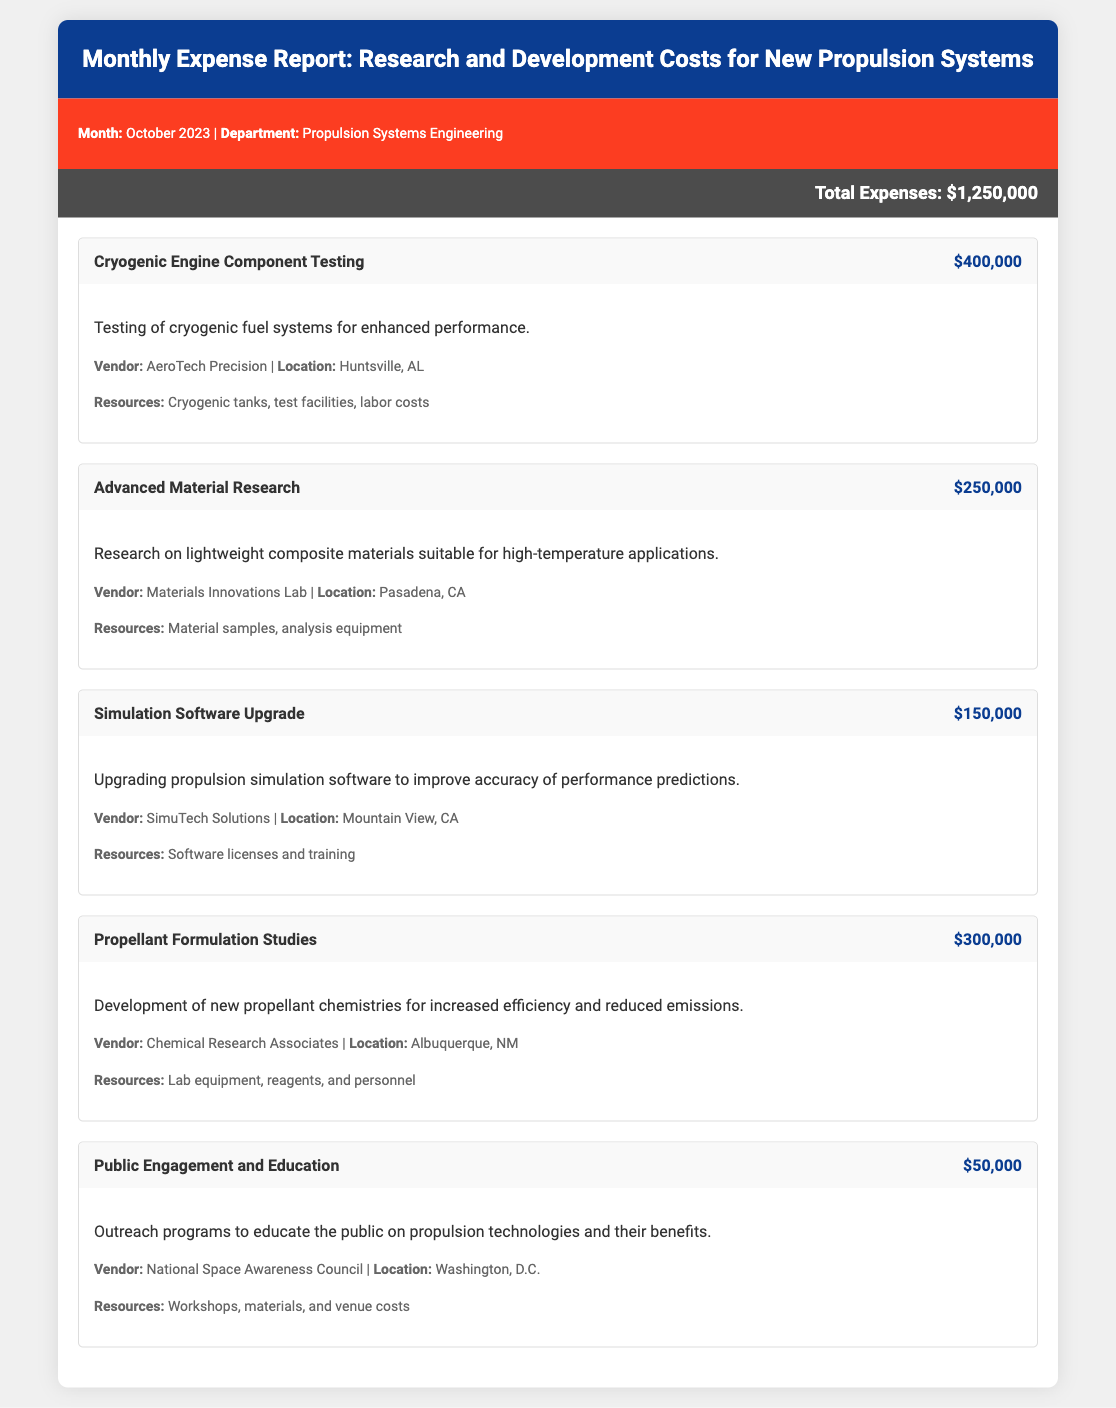What is the total expense for October 2023? The total expense is explicitly stated in the document, which is $1,250,000.
Answer: $1,250,000 How much was spent on Cryogenic Engine Component Testing? The expenditure for Cryogenic Engine Component Testing is indicated in the document as $400,000.
Answer: $400,000 Which vendor was involved in Advanced Material Research? The document lists the vendor for Advanced Material Research as Materials Innovations Lab.
Answer: Materials Innovations Lab What is the location of the vendor for Simulation Software Upgrade? The document specifies that the vendor's location for Simulation Software Upgrade is Mountain View, CA.
Answer: Mountain View, CA How many activities are listed in the report? The document lists a total of five activities associated with the expenses.
Answer: Five Which activity has the highest expenditure? The report states that Cryogenic Engine Component Testing has the highest expenditure of $400,000.
Answer: Cryogenic Engine Component Testing What type of outreach was funded with the allocated $50,000? The document indicates that the $50,000 was for Public Engagement and Education.
Answer: Public Engagement and Education What resources were used in Propellant Formulation Studies? The document details that lab equipment, reagents, and personnel were the resources used in Propellant Formulation Studies.
Answer: Lab equipment, reagents, and personnel What is the purpose of the funds allocated to Public Engagement and Education? The document describes the purpose as outreach programs to educate the public on propulsion technologies and their benefits.
Answer: Outreach programs to educate the public on propulsion technologies What was the focus of the Advanced Material Research? The document states that Advanced Material Research focused on lightweight composite materials suitable for high-temperature applications.
Answer: Lightweight composite materials suitable for high-temperature applications 